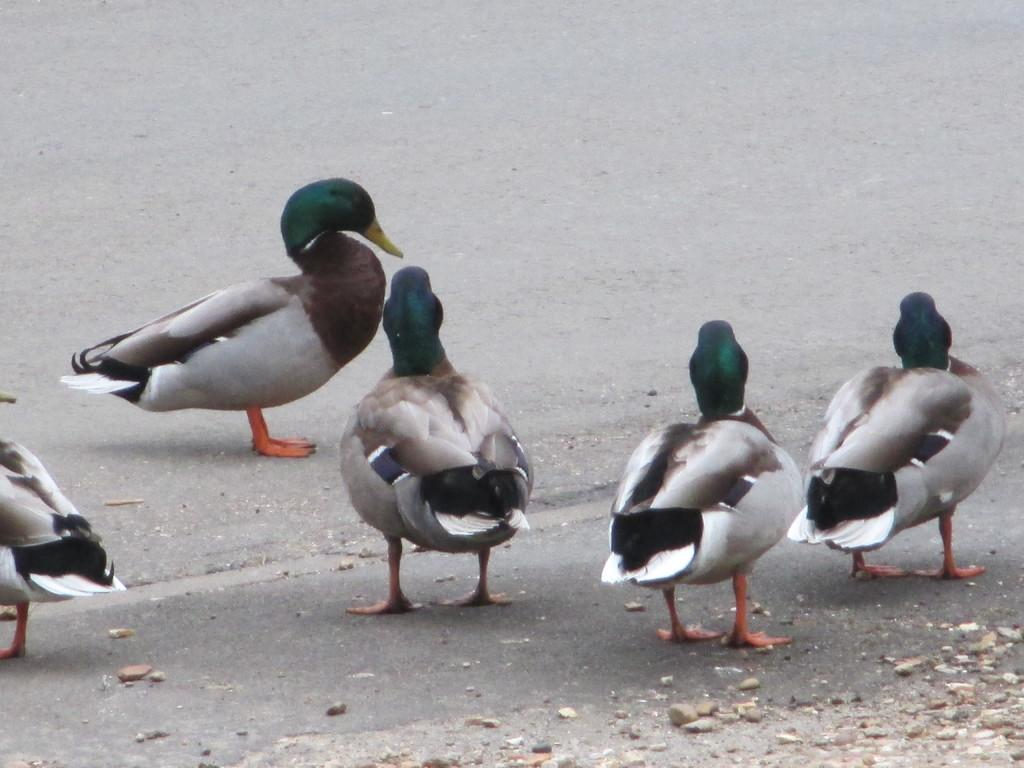What animals are present in the image? There are ducks in the image. Where are the ducks located? The ducks are on the road. What colors can be seen on the ducks? The ducks have various colors, including white, black, brown, and green. What type of stove can be seen in the image? There is no stove present in the image; it features ducks on the road. How many turkeys are visible in the image? There are no turkeys visible in the image; it features ducks on the road. 